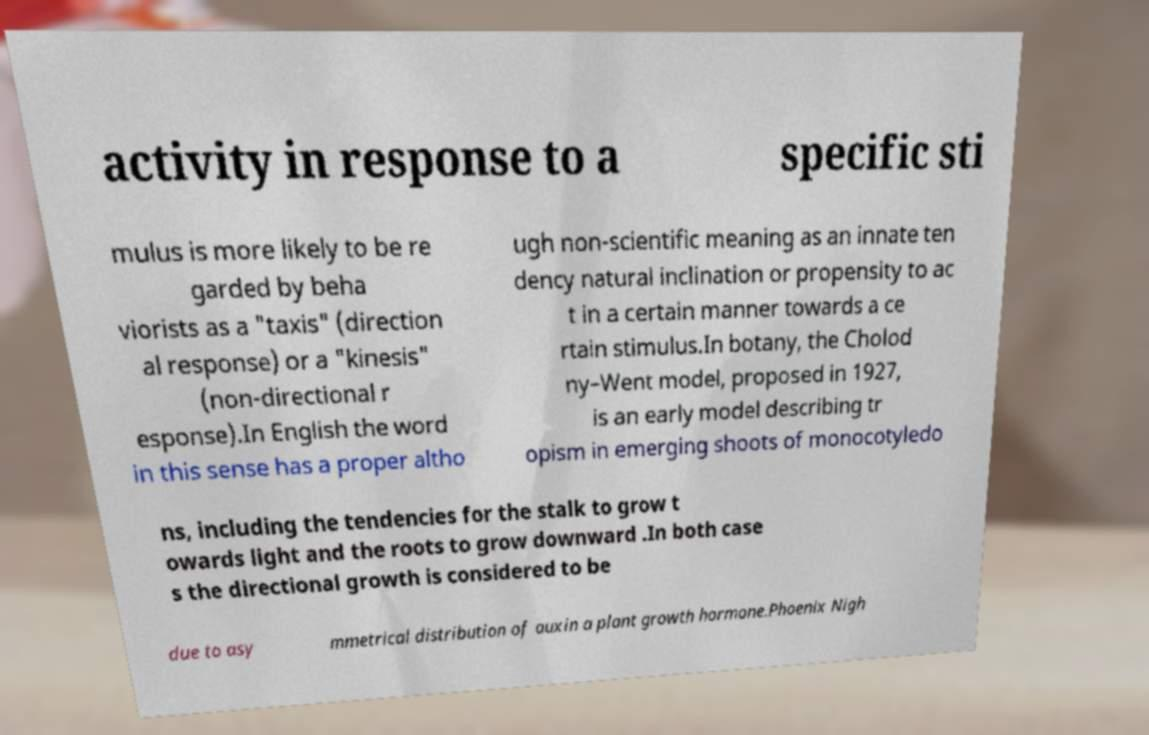Can you read and provide the text displayed in the image?This photo seems to have some interesting text. Can you extract and type it out for me? activity in response to a specific sti mulus is more likely to be re garded by beha viorists as a "taxis" (direction al response) or a "kinesis" (non-directional r esponse).In English the word in this sense has a proper altho ugh non-scientific meaning as an innate ten dency natural inclination or propensity to ac t in a certain manner towards a ce rtain stimulus.In botany, the Cholod ny–Went model, proposed in 1927, is an early model describing tr opism in emerging shoots of monocotyledo ns, including the tendencies for the stalk to grow t owards light and the roots to grow downward .In both case s the directional growth is considered to be due to asy mmetrical distribution of auxin a plant growth hormone.Phoenix Nigh 